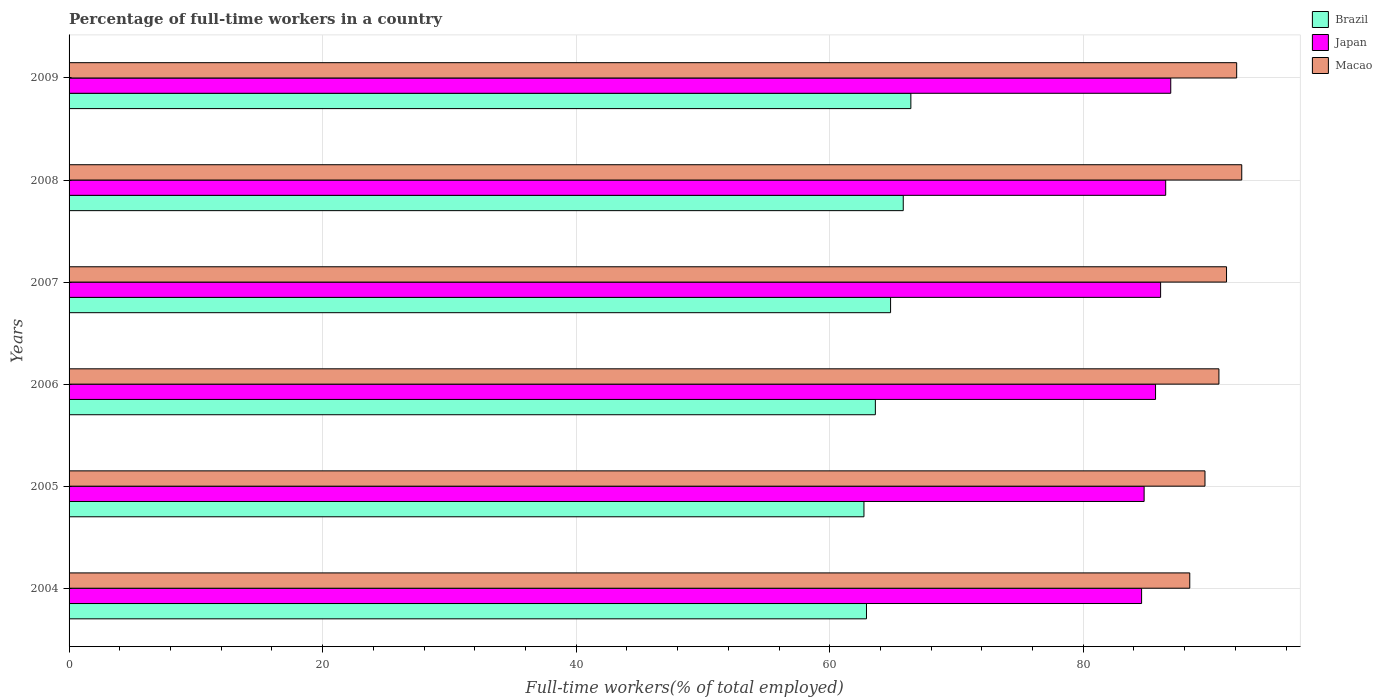How many groups of bars are there?
Your answer should be compact. 6. How many bars are there on the 6th tick from the bottom?
Ensure brevity in your answer.  3. What is the percentage of full-time workers in Brazil in 2008?
Make the answer very short. 65.8. Across all years, what is the maximum percentage of full-time workers in Macao?
Offer a very short reply. 92.5. Across all years, what is the minimum percentage of full-time workers in Macao?
Offer a terse response. 88.4. In which year was the percentage of full-time workers in Japan minimum?
Provide a succinct answer. 2004. What is the total percentage of full-time workers in Brazil in the graph?
Your answer should be compact. 386.2. What is the difference between the percentage of full-time workers in Macao in 2006 and that in 2007?
Keep it short and to the point. -0.6. What is the difference between the percentage of full-time workers in Brazil in 2005 and the percentage of full-time workers in Japan in 2007?
Provide a succinct answer. -23.4. What is the average percentage of full-time workers in Japan per year?
Provide a short and direct response. 85.77. What is the ratio of the percentage of full-time workers in Brazil in 2007 to that in 2008?
Make the answer very short. 0.98. Is the percentage of full-time workers in Japan in 2007 less than that in 2009?
Your response must be concise. Yes. What is the difference between the highest and the second highest percentage of full-time workers in Brazil?
Offer a very short reply. 0.6. What is the difference between the highest and the lowest percentage of full-time workers in Japan?
Ensure brevity in your answer.  2.3. What does the 3rd bar from the bottom in 2009 represents?
Provide a short and direct response. Macao. How many bars are there?
Your response must be concise. 18. Are all the bars in the graph horizontal?
Your answer should be very brief. Yes. What is the difference between two consecutive major ticks on the X-axis?
Make the answer very short. 20. Does the graph contain any zero values?
Make the answer very short. No. Does the graph contain grids?
Make the answer very short. Yes. How many legend labels are there?
Ensure brevity in your answer.  3. How are the legend labels stacked?
Give a very brief answer. Vertical. What is the title of the graph?
Give a very brief answer. Percentage of full-time workers in a country. Does "Greenland" appear as one of the legend labels in the graph?
Keep it short and to the point. No. What is the label or title of the X-axis?
Keep it short and to the point. Full-time workers(% of total employed). What is the label or title of the Y-axis?
Give a very brief answer. Years. What is the Full-time workers(% of total employed) in Brazil in 2004?
Your response must be concise. 62.9. What is the Full-time workers(% of total employed) in Japan in 2004?
Keep it short and to the point. 84.6. What is the Full-time workers(% of total employed) in Macao in 2004?
Provide a short and direct response. 88.4. What is the Full-time workers(% of total employed) of Brazil in 2005?
Your response must be concise. 62.7. What is the Full-time workers(% of total employed) in Japan in 2005?
Your answer should be very brief. 84.8. What is the Full-time workers(% of total employed) of Macao in 2005?
Your answer should be very brief. 89.6. What is the Full-time workers(% of total employed) in Brazil in 2006?
Offer a terse response. 63.6. What is the Full-time workers(% of total employed) in Japan in 2006?
Your response must be concise. 85.7. What is the Full-time workers(% of total employed) in Macao in 2006?
Give a very brief answer. 90.7. What is the Full-time workers(% of total employed) in Brazil in 2007?
Offer a terse response. 64.8. What is the Full-time workers(% of total employed) in Japan in 2007?
Provide a short and direct response. 86.1. What is the Full-time workers(% of total employed) of Macao in 2007?
Give a very brief answer. 91.3. What is the Full-time workers(% of total employed) in Brazil in 2008?
Offer a terse response. 65.8. What is the Full-time workers(% of total employed) of Japan in 2008?
Offer a very short reply. 86.5. What is the Full-time workers(% of total employed) in Macao in 2008?
Provide a succinct answer. 92.5. What is the Full-time workers(% of total employed) in Brazil in 2009?
Offer a very short reply. 66.4. What is the Full-time workers(% of total employed) in Japan in 2009?
Provide a short and direct response. 86.9. What is the Full-time workers(% of total employed) in Macao in 2009?
Ensure brevity in your answer.  92.1. Across all years, what is the maximum Full-time workers(% of total employed) in Brazil?
Provide a succinct answer. 66.4. Across all years, what is the maximum Full-time workers(% of total employed) in Japan?
Offer a very short reply. 86.9. Across all years, what is the maximum Full-time workers(% of total employed) of Macao?
Ensure brevity in your answer.  92.5. Across all years, what is the minimum Full-time workers(% of total employed) of Brazil?
Your answer should be compact. 62.7. Across all years, what is the minimum Full-time workers(% of total employed) in Japan?
Ensure brevity in your answer.  84.6. Across all years, what is the minimum Full-time workers(% of total employed) of Macao?
Keep it short and to the point. 88.4. What is the total Full-time workers(% of total employed) of Brazil in the graph?
Offer a very short reply. 386.2. What is the total Full-time workers(% of total employed) of Japan in the graph?
Ensure brevity in your answer.  514.6. What is the total Full-time workers(% of total employed) in Macao in the graph?
Offer a terse response. 544.6. What is the difference between the Full-time workers(% of total employed) of Brazil in 2004 and that in 2005?
Provide a short and direct response. 0.2. What is the difference between the Full-time workers(% of total employed) in Japan in 2004 and that in 2005?
Your response must be concise. -0.2. What is the difference between the Full-time workers(% of total employed) in Brazil in 2004 and that in 2006?
Make the answer very short. -0.7. What is the difference between the Full-time workers(% of total employed) of Japan in 2004 and that in 2006?
Give a very brief answer. -1.1. What is the difference between the Full-time workers(% of total employed) of Brazil in 2004 and that in 2007?
Offer a terse response. -1.9. What is the difference between the Full-time workers(% of total employed) of Macao in 2004 and that in 2007?
Provide a succinct answer. -2.9. What is the difference between the Full-time workers(% of total employed) in Macao in 2004 and that in 2008?
Offer a terse response. -4.1. What is the difference between the Full-time workers(% of total employed) of Japan in 2004 and that in 2009?
Your answer should be compact. -2.3. What is the difference between the Full-time workers(% of total employed) of Macao in 2004 and that in 2009?
Give a very brief answer. -3.7. What is the difference between the Full-time workers(% of total employed) in Japan in 2005 and that in 2006?
Give a very brief answer. -0.9. What is the difference between the Full-time workers(% of total employed) in Brazil in 2005 and that in 2008?
Your response must be concise. -3.1. What is the difference between the Full-time workers(% of total employed) of Japan in 2005 and that in 2008?
Offer a very short reply. -1.7. What is the difference between the Full-time workers(% of total employed) of Brazil in 2005 and that in 2009?
Give a very brief answer. -3.7. What is the difference between the Full-time workers(% of total employed) in Brazil in 2006 and that in 2007?
Ensure brevity in your answer.  -1.2. What is the difference between the Full-time workers(% of total employed) of Japan in 2006 and that in 2007?
Your answer should be compact. -0.4. What is the difference between the Full-time workers(% of total employed) in Macao in 2006 and that in 2007?
Keep it short and to the point. -0.6. What is the difference between the Full-time workers(% of total employed) of Japan in 2006 and that in 2008?
Your answer should be compact. -0.8. What is the difference between the Full-time workers(% of total employed) in Macao in 2006 and that in 2008?
Your response must be concise. -1.8. What is the difference between the Full-time workers(% of total employed) in Japan in 2006 and that in 2009?
Your answer should be very brief. -1.2. What is the difference between the Full-time workers(% of total employed) of Macao in 2006 and that in 2009?
Your answer should be compact. -1.4. What is the difference between the Full-time workers(% of total employed) of Brazil in 2007 and that in 2008?
Offer a very short reply. -1. What is the difference between the Full-time workers(% of total employed) of Japan in 2007 and that in 2008?
Offer a terse response. -0.4. What is the difference between the Full-time workers(% of total employed) of Macao in 2007 and that in 2008?
Your answer should be compact. -1.2. What is the difference between the Full-time workers(% of total employed) in Brazil in 2007 and that in 2009?
Offer a very short reply. -1.6. What is the difference between the Full-time workers(% of total employed) of Macao in 2007 and that in 2009?
Give a very brief answer. -0.8. What is the difference between the Full-time workers(% of total employed) in Japan in 2008 and that in 2009?
Make the answer very short. -0.4. What is the difference between the Full-time workers(% of total employed) of Brazil in 2004 and the Full-time workers(% of total employed) of Japan in 2005?
Your answer should be compact. -21.9. What is the difference between the Full-time workers(% of total employed) in Brazil in 2004 and the Full-time workers(% of total employed) in Macao in 2005?
Your response must be concise. -26.7. What is the difference between the Full-time workers(% of total employed) in Brazil in 2004 and the Full-time workers(% of total employed) in Japan in 2006?
Provide a short and direct response. -22.8. What is the difference between the Full-time workers(% of total employed) in Brazil in 2004 and the Full-time workers(% of total employed) in Macao in 2006?
Your answer should be compact. -27.8. What is the difference between the Full-time workers(% of total employed) of Brazil in 2004 and the Full-time workers(% of total employed) of Japan in 2007?
Give a very brief answer. -23.2. What is the difference between the Full-time workers(% of total employed) in Brazil in 2004 and the Full-time workers(% of total employed) in Macao in 2007?
Your answer should be very brief. -28.4. What is the difference between the Full-time workers(% of total employed) of Japan in 2004 and the Full-time workers(% of total employed) of Macao in 2007?
Your answer should be compact. -6.7. What is the difference between the Full-time workers(% of total employed) in Brazil in 2004 and the Full-time workers(% of total employed) in Japan in 2008?
Offer a very short reply. -23.6. What is the difference between the Full-time workers(% of total employed) of Brazil in 2004 and the Full-time workers(% of total employed) of Macao in 2008?
Keep it short and to the point. -29.6. What is the difference between the Full-time workers(% of total employed) of Japan in 2004 and the Full-time workers(% of total employed) of Macao in 2008?
Give a very brief answer. -7.9. What is the difference between the Full-time workers(% of total employed) in Brazil in 2004 and the Full-time workers(% of total employed) in Japan in 2009?
Offer a terse response. -24. What is the difference between the Full-time workers(% of total employed) of Brazil in 2004 and the Full-time workers(% of total employed) of Macao in 2009?
Ensure brevity in your answer.  -29.2. What is the difference between the Full-time workers(% of total employed) in Brazil in 2005 and the Full-time workers(% of total employed) in Japan in 2006?
Give a very brief answer. -23. What is the difference between the Full-time workers(% of total employed) of Japan in 2005 and the Full-time workers(% of total employed) of Macao in 2006?
Give a very brief answer. -5.9. What is the difference between the Full-time workers(% of total employed) in Brazil in 2005 and the Full-time workers(% of total employed) in Japan in 2007?
Offer a very short reply. -23.4. What is the difference between the Full-time workers(% of total employed) of Brazil in 2005 and the Full-time workers(% of total employed) of Macao in 2007?
Provide a succinct answer. -28.6. What is the difference between the Full-time workers(% of total employed) of Brazil in 2005 and the Full-time workers(% of total employed) of Japan in 2008?
Your response must be concise. -23.8. What is the difference between the Full-time workers(% of total employed) of Brazil in 2005 and the Full-time workers(% of total employed) of Macao in 2008?
Keep it short and to the point. -29.8. What is the difference between the Full-time workers(% of total employed) in Japan in 2005 and the Full-time workers(% of total employed) in Macao in 2008?
Give a very brief answer. -7.7. What is the difference between the Full-time workers(% of total employed) in Brazil in 2005 and the Full-time workers(% of total employed) in Japan in 2009?
Your answer should be compact. -24.2. What is the difference between the Full-time workers(% of total employed) of Brazil in 2005 and the Full-time workers(% of total employed) of Macao in 2009?
Provide a short and direct response. -29.4. What is the difference between the Full-time workers(% of total employed) in Japan in 2005 and the Full-time workers(% of total employed) in Macao in 2009?
Give a very brief answer. -7.3. What is the difference between the Full-time workers(% of total employed) in Brazil in 2006 and the Full-time workers(% of total employed) in Japan in 2007?
Provide a short and direct response. -22.5. What is the difference between the Full-time workers(% of total employed) of Brazil in 2006 and the Full-time workers(% of total employed) of Macao in 2007?
Provide a succinct answer. -27.7. What is the difference between the Full-time workers(% of total employed) of Japan in 2006 and the Full-time workers(% of total employed) of Macao in 2007?
Your answer should be compact. -5.6. What is the difference between the Full-time workers(% of total employed) in Brazil in 2006 and the Full-time workers(% of total employed) in Japan in 2008?
Give a very brief answer. -22.9. What is the difference between the Full-time workers(% of total employed) in Brazil in 2006 and the Full-time workers(% of total employed) in Macao in 2008?
Your response must be concise. -28.9. What is the difference between the Full-time workers(% of total employed) of Brazil in 2006 and the Full-time workers(% of total employed) of Japan in 2009?
Keep it short and to the point. -23.3. What is the difference between the Full-time workers(% of total employed) in Brazil in 2006 and the Full-time workers(% of total employed) in Macao in 2009?
Your answer should be compact. -28.5. What is the difference between the Full-time workers(% of total employed) of Japan in 2006 and the Full-time workers(% of total employed) of Macao in 2009?
Offer a very short reply. -6.4. What is the difference between the Full-time workers(% of total employed) of Brazil in 2007 and the Full-time workers(% of total employed) of Japan in 2008?
Keep it short and to the point. -21.7. What is the difference between the Full-time workers(% of total employed) in Brazil in 2007 and the Full-time workers(% of total employed) in Macao in 2008?
Provide a succinct answer. -27.7. What is the difference between the Full-time workers(% of total employed) in Brazil in 2007 and the Full-time workers(% of total employed) in Japan in 2009?
Provide a succinct answer. -22.1. What is the difference between the Full-time workers(% of total employed) of Brazil in 2007 and the Full-time workers(% of total employed) of Macao in 2009?
Your answer should be compact. -27.3. What is the difference between the Full-time workers(% of total employed) in Brazil in 2008 and the Full-time workers(% of total employed) in Japan in 2009?
Offer a terse response. -21.1. What is the difference between the Full-time workers(% of total employed) in Brazil in 2008 and the Full-time workers(% of total employed) in Macao in 2009?
Give a very brief answer. -26.3. What is the average Full-time workers(% of total employed) in Brazil per year?
Offer a very short reply. 64.37. What is the average Full-time workers(% of total employed) of Japan per year?
Your answer should be very brief. 85.77. What is the average Full-time workers(% of total employed) of Macao per year?
Offer a very short reply. 90.77. In the year 2004, what is the difference between the Full-time workers(% of total employed) in Brazil and Full-time workers(% of total employed) in Japan?
Give a very brief answer. -21.7. In the year 2004, what is the difference between the Full-time workers(% of total employed) in Brazil and Full-time workers(% of total employed) in Macao?
Provide a short and direct response. -25.5. In the year 2005, what is the difference between the Full-time workers(% of total employed) of Brazil and Full-time workers(% of total employed) of Japan?
Give a very brief answer. -22.1. In the year 2005, what is the difference between the Full-time workers(% of total employed) of Brazil and Full-time workers(% of total employed) of Macao?
Offer a very short reply. -26.9. In the year 2005, what is the difference between the Full-time workers(% of total employed) of Japan and Full-time workers(% of total employed) of Macao?
Provide a short and direct response. -4.8. In the year 2006, what is the difference between the Full-time workers(% of total employed) in Brazil and Full-time workers(% of total employed) in Japan?
Keep it short and to the point. -22.1. In the year 2006, what is the difference between the Full-time workers(% of total employed) in Brazil and Full-time workers(% of total employed) in Macao?
Provide a succinct answer. -27.1. In the year 2006, what is the difference between the Full-time workers(% of total employed) in Japan and Full-time workers(% of total employed) in Macao?
Offer a terse response. -5. In the year 2007, what is the difference between the Full-time workers(% of total employed) of Brazil and Full-time workers(% of total employed) of Japan?
Keep it short and to the point. -21.3. In the year 2007, what is the difference between the Full-time workers(% of total employed) of Brazil and Full-time workers(% of total employed) of Macao?
Provide a short and direct response. -26.5. In the year 2008, what is the difference between the Full-time workers(% of total employed) in Brazil and Full-time workers(% of total employed) in Japan?
Your answer should be compact. -20.7. In the year 2008, what is the difference between the Full-time workers(% of total employed) of Brazil and Full-time workers(% of total employed) of Macao?
Give a very brief answer. -26.7. In the year 2008, what is the difference between the Full-time workers(% of total employed) of Japan and Full-time workers(% of total employed) of Macao?
Give a very brief answer. -6. In the year 2009, what is the difference between the Full-time workers(% of total employed) in Brazil and Full-time workers(% of total employed) in Japan?
Offer a terse response. -20.5. In the year 2009, what is the difference between the Full-time workers(% of total employed) in Brazil and Full-time workers(% of total employed) in Macao?
Keep it short and to the point. -25.7. What is the ratio of the Full-time workers(% of total employed) in Brazil in 2004 to that in 2005?
Keep it short and to the point. 1. What is the ratio of the Full-time workers(% of total employed) of Japan in 2004 to that in 2005?
Your answer should be very brief. 1. What is the ratio of the Full-time workers(% of total employed) in Macao in 2004 to that in 2005?
Make the answer very short. 0.99. What is the ratio of the Full-time workers(% of total employed) of Japan in 2004 to that in 2006?
Give a very brief answer. 0.99. What is the ratio of the Full-time workers(% of total employed) in Macao in 2004 to that in 2006?
Keep it short and to the point. 0.97. What is the ratio of the Full-time workers(% of total employed) in Brazil in 2004 to that in 2007?
Your answer should be compact. 0.97. What is the ratio of the Full-time workers(% of total employed) in Japan in 2004 to that in 2007?
Offer a terse response. 0.98. What is the ratio of the Full-time workers(% of total employed) in Macao in 2004 to that in 2007?
Offer a very short reply. 0.97. What is the ratio of the Full-time workers(% of total employed) of Brazil in 2004 to that in 2008?
Offer a very short reply. 0.96. What is the ratio of the Full-time workers(% of total employed) of Macao in 2004 to that in 2008?
Your response must be concise. 0.96. What is the ratio of the Full-time workers(% of total employed) in Brazil in 2004 to that in 2009?
Provide a succinct answer. 0.95. What is the ratio of the Full-time workers(% of total employed) in Japan in 2004 to that in 2009?
Provide a short and direct response. 0.97. What is the ratio of the Full-time workers(% of total employed) of Macao in 2004 to that in 2009?
Your response must be concise. 0.96. What is the ratio of the Full-time workers(% of total employed) of Brazil in 2005 to that in 2006?
Keep it short and to the point. 0.99. What is the ratio of the Full-time workers(% of total employed) of Japan in 2005 to that in 2006?
Offer a terse response. 0.99. What is the ratio of the Full-time workers(% of total employed) in Macao in 2005 to that in 2006?
Your answer should be compact. 0.99. What is the ratio of the Full-time workers(% of total employed) of Brazil in 2005 to that in 2007?
Ensure brevity in your answer.  0.97. What is the ratio of the Full-time workers(% of total employed) in Japan in 2005 to that in 2007?
Give a very brief answer. 0.98. What is the ratio of the Full-time workers(% of total employed) in Macao in 2005 to that in 2007?
Your answer should be very brief. 0.98. What is the ratio of the Full-time workers(% of total employed) of Brazil in 2005 to that in 2008?
Your answer should be very brief. 0.95. What is the ratio of the Full-time workers(% of total employed) of Japan in 2005 to that in 2008?
Ensure brevity in your answer.  0.98. What is the ratio of the Full-time workers(% of total employed) of Macao in 2005 to that in 2008?
Provide a succinct answer. 0.97. What is the ratio of the Full-time workers(% of total employed) in Brazil in 2005 to that in 2009?
Ensure brevity in your answer.  0.94. What is the ratio of the Full-time workers(% of total employed) in Japan in 2005 to that in 2009?
Make the answer very short. 0.98. What is the ratio of the Full-time workers(% of total employed) in Macao in 2005 to that in 2009?
Offer a terse response. 0.97. What is the ratio of the Full-time workers(% of total employed) in Brazil in 2006 to that in 2007?
Provide a succinct answer. 0.98. What is the ratio of the Full-time workers(% of total employed) in Japan in 2006 to that in 2007?
Keep it short and to the point. 1. What is the ratio of the Full-time workers(% of total employed) of Brazil in 2006 to that in 2008?
Your answer should be very brief. 0.97. What is the ratio of the Full-time workers(% of total employed) in Japan in 2006 to that in 2008?
Keep it short and to the point. 0.99. What is the ratio of the Full-time workers(% of total employed) in Macao in 2006 to that in 2008?
Make the answer very short. 0.98. What is the ratio of the Full-time workers(% of total employed) in Brazil in 2006 to that in 2009?
Your answer should be very brief. 0.96. What is the ratio of the Full-time workers(% of total employed) of Japan in 2006 to that in 2009?
Offer a very short reply. 0.99. What is the ratio of the Full-time workers(% of total employed) in Macao in 2006 to that in 2009?
Offer a terse response. 0.98. What is the ratio of the Full-time workers(% of total employed) of Japan in 2007 to that in 2008?
Your answer should be compact. 1. What is the ratio of the Full-time workers(% of total employed) of Macao in 2007 to that in 2008?
Provide a short and direct response. 0.99. What is the ratio of the Full-time workers(% of total employed) in Brazil in 2007 to that in 2009?
Offer a very short reply. 0.98. What is the ratio of the Full-time workers(% of total employed) in Macao in 2007 to that in 2009?
Ensure brevity in your answer.  0.99. What is the ratio of the Full-time workers(% of total employed) in Japan in 2008 to that in 2009?
Provide a succinct answer. 1. What is the difference between the highest and the second highest Full-time workers(% of total employed) in Brazil?
Give a very brief answer. 0.6. What is the difference between the highest and the second highest Full-time workers(% of total employed) in Japan?
Give a very brief answer. 0.4. What is the difference between the highest and the lowest Full-time workers(% of total employed) of Brazil?
Keep it short and to the point. 3.7. 